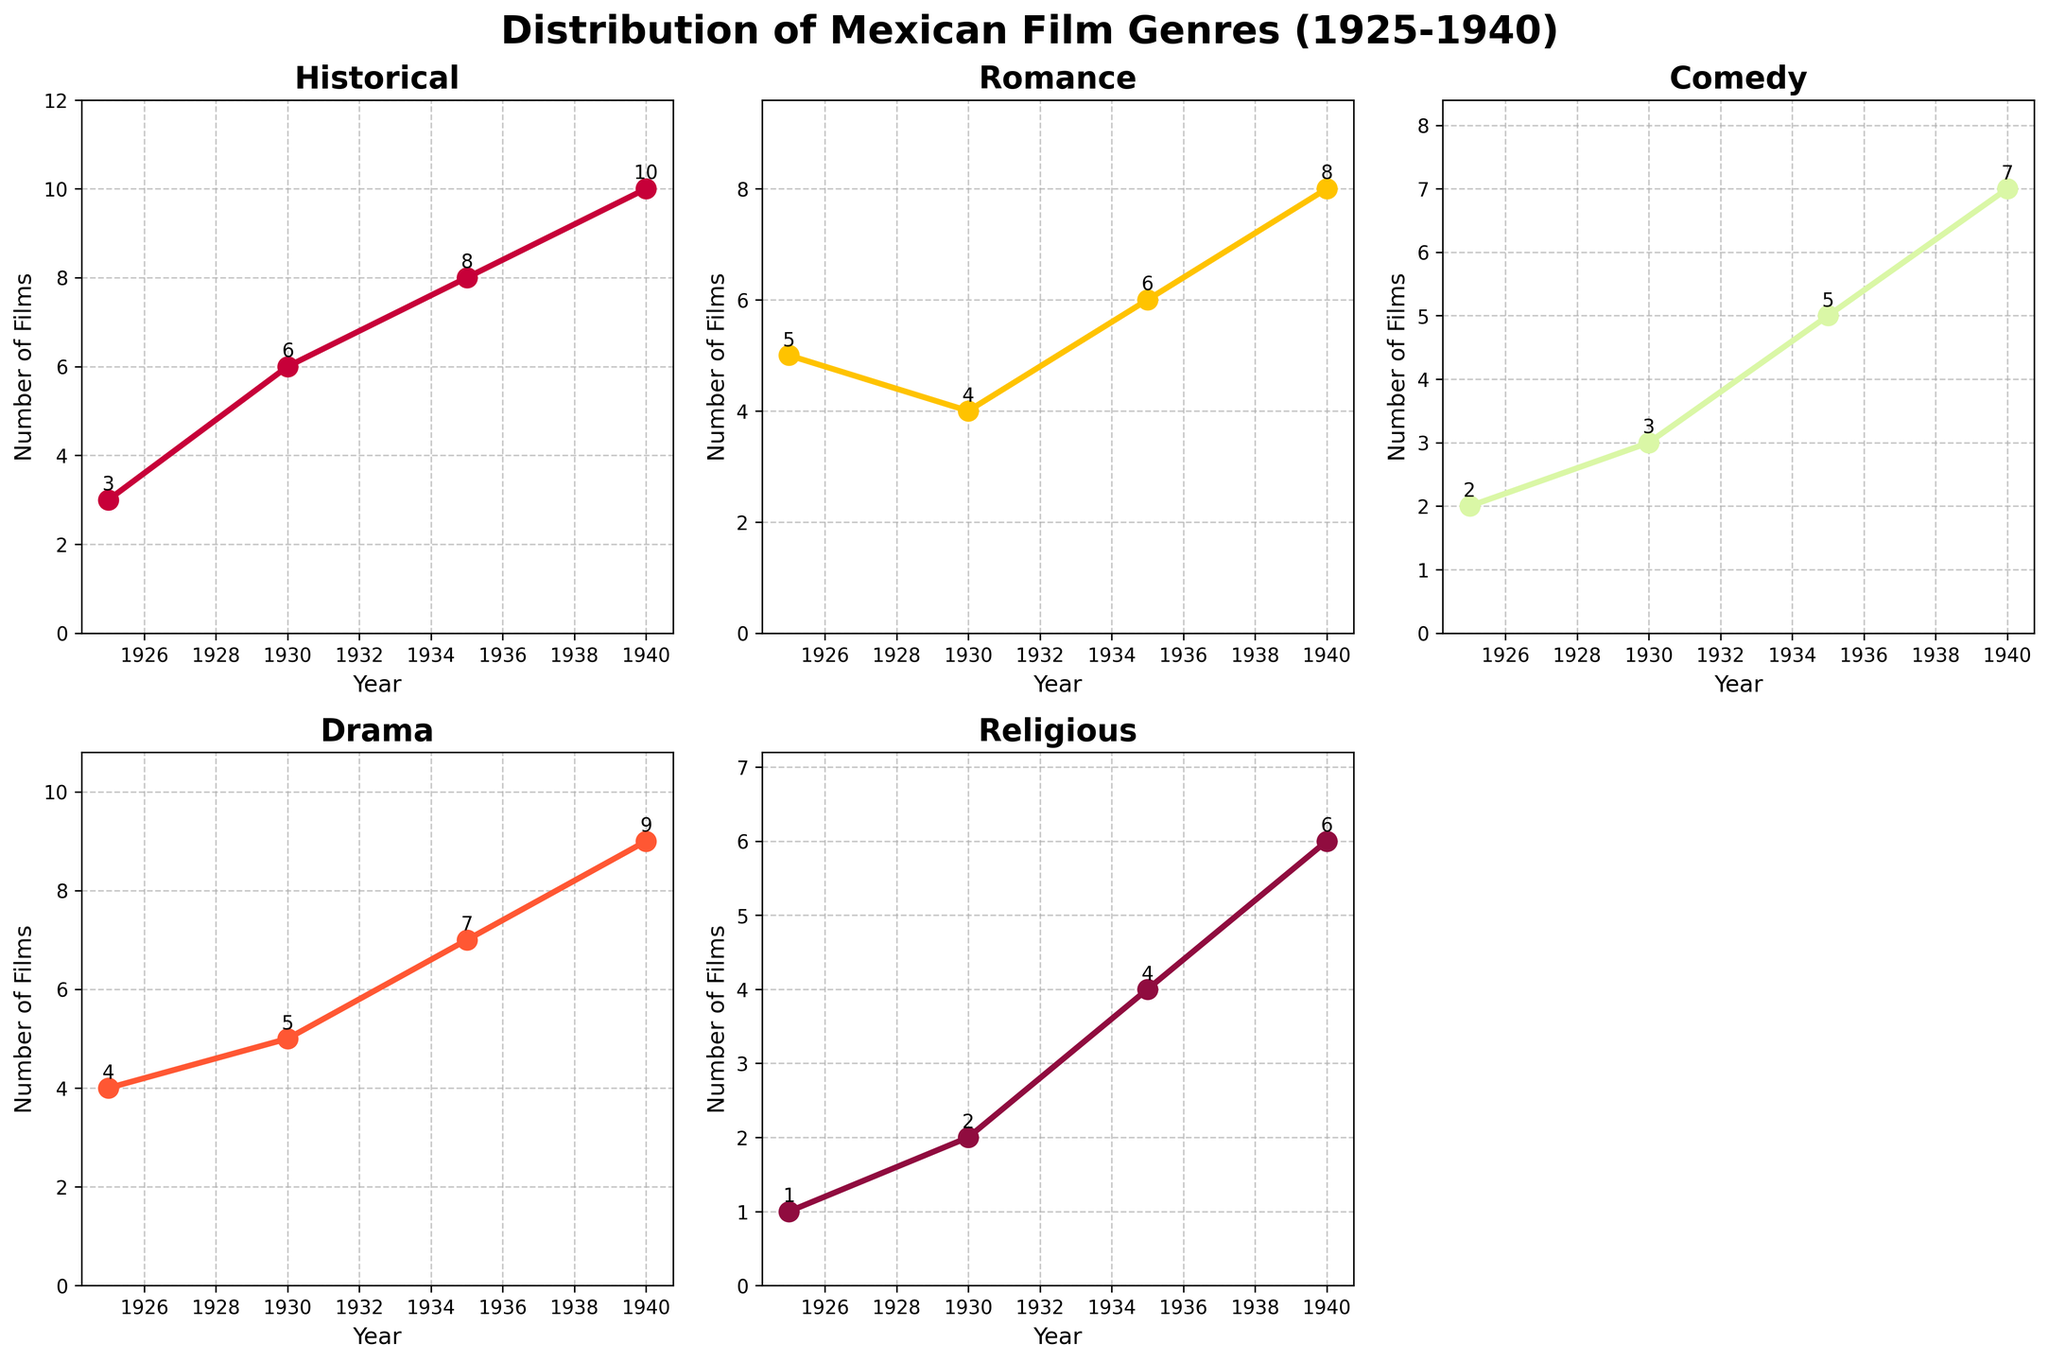what years are displayed in the figure? The x-axis labels display the years at which the distribution for each genre is measured. These include the years 1925, 1930, 1935, and 1940. By looking at any subplot, you can see these years represented.
Answer: 1925, 1930, 1935, 1940 what is the total number of romance films produced in 1935? The sub-plot for Romance films has data points for each year, with an annotation showing the exact number of films. For the year 1935, the number is 6.
Answer: 6 which genre has the highest number of films produced in 1940? To determine this, compare the y-values (and their annotations) for each genre in the year 1940 across the subplots. The 'Historical' genre has the highest number of films, which is 10.
Answer: Historical which genre shows the smallest increase in the number of films from 1925 to 1940? Subtract the 1925 value from the 1940 value for each genre subplot: Historical (10-3), Romance (8-5), Comedy (7-5), Drama (9-4), Religious (6-1). The smallest increase is for Romance (3 films).
Answer: Romance what is the average number of comedy films produced across all years? Sum the number of Comedy films produced in each year (2+3+5+7) and divide by the number of years (4). The total is 17, so the average is 17/4.
Answer: 4.25 how does the trend for religious films compare to historical films from 1925 to 1940? Look at the increase for each year and overall trend. Both genres exhibit an increasing trend but the slope for Historical is steeper (more rapid increase). Historical films rise from 3 to 10, whereas Religious films rise from 1 to 6.
Answer: Historical increases more steeply which genre had a sudden increase or decrease in any particular year? By examining the slope between consecutive points in each subplot, Historical films show a sudden increase between 1935 and 1940, going from 8 to 10.
Answer: Historical (1935 to 1940) how many subplots are there in the grid, and how many are not displaying data? There are 6 subplots, arranged in a 2x3 grid. One subplot in the bottom right corner does not display any data (it is blank).
Answer: 6 subplots, 1 blank how many more drama films were made in 1940 compared to 1925? Subtract the number of drama films in 1925 (4) from those in 1940 (9). The difference is 9-4 = 5.
Answer: 5 